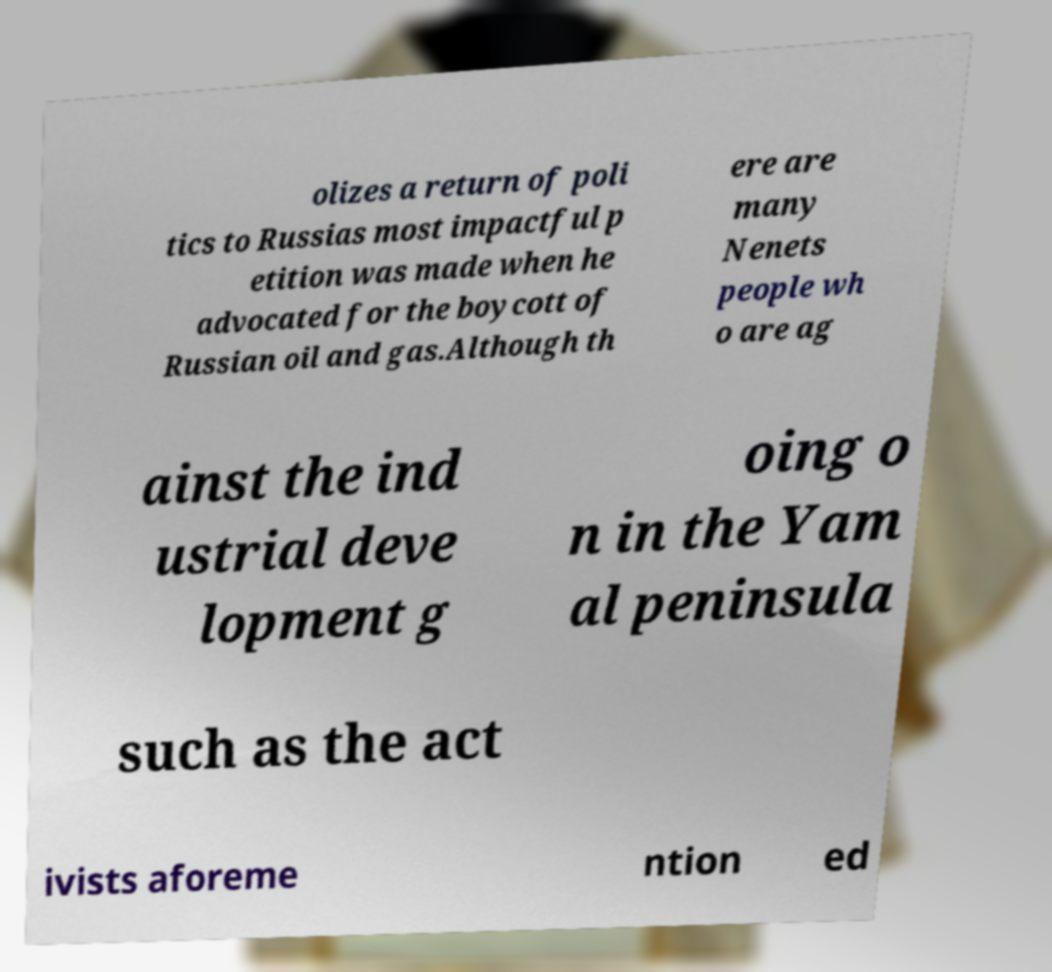Can you accurately transcribe the text from the provided image for me? olizes a return of poli tics to Russias most impactful p etition was made when he advocated for the boycott of Russian oil and gas.Although th ere are many Nenets people wh o are ag ainst the ind ustrial deve lopment g oing o n in the Yam al peninsula such as the act ivists aforeme ntion ed 